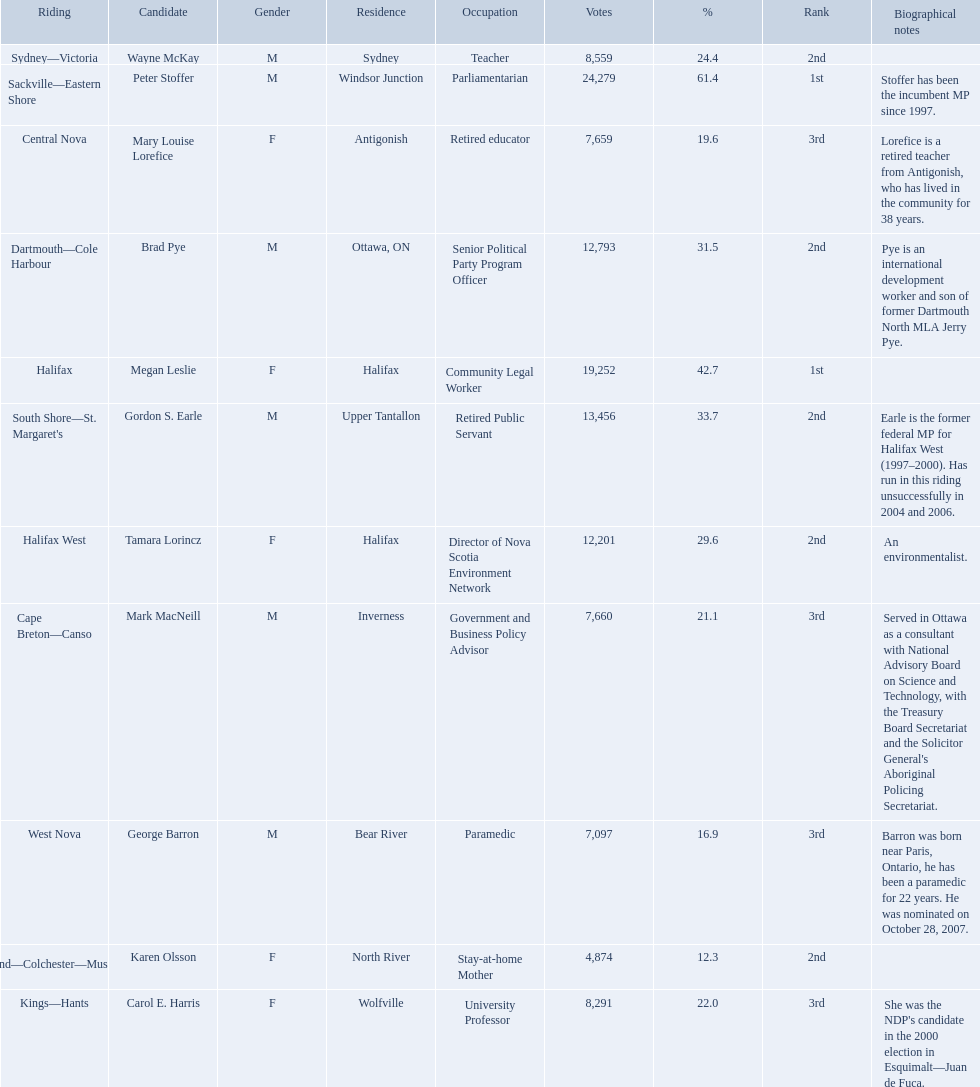Who were the new democratic party candidates, 2008? Mark MacNeill, Mary Louise Lorefice, Karen Olsson, Brad Pye, Megan Leslie, Tamara Lorincz, Carol E. Harris, Peter Stoffer, Gordon S. Earle, Wayne McKay, George Barron. Who had the 2nd highest number of votes? Megan Leslie, Peter Stoffer. How many votes did she receive? 19,252. Who are all the candidates? Mark MacNeill, Mary Louise Lorefice, Karen Olsson, Brad Pye, Megan Leslie, Tamara Lorincz, Carol E. Harris, Peter Stoffer, Gordon S. Earle, Wayne McKay, George Barron. How many votes did they receive? 7,660, 7,659, 4,874, 12,793, 19,252, 12,201, 8,291, 24,279, 13,456, 8,559, 7,097. And of those, how many were for megan leslie? 19,252. 